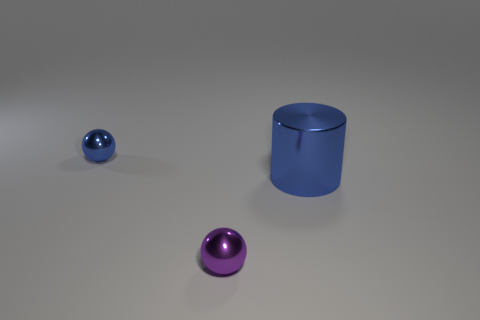How many tiny metal spheres have the same color as the large object?
Provide a succinct answer. 1. There is a purple sphere; does it have the same size as the blue metallic object behind the large thing?
Ensure brevity in your answer.  Yes. How big is the blue thing that is on the right side of the tiny shiny thing that is in front of the tiny shiny thing that is behind the large blue thing?
Ensure brevity in your answer.  Large. How many purple metallic balls are in front of the tiny purple thing?
Offer a very short reply. 0. Is there anything else that is the same size as the shiny cylinder?
Offer a terse response. No. Do the cylinder and the purple metallic sphere have the same size?
Provide a succinct answer. No. How many things are either tiny shiny spheres behind the shiny cylinder or shiny things in front of the blue shiny ball?
Provide a short and direct response. 3. Is the number of tiny metallic balls in front of the big blue cylinder greater than the number of small metallic cubes?
Keep it short and to the point. Yes. What number of other things are the same shape as the tiny blue shiny thing?
Provide a succinct answer. 1. How many objects are either big red things or blue cylinders?
Provide a succinct answer. 1. 